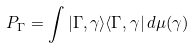Convert formula to latex. <formula><loc_0><loc_0><loc_500><loc_500>P _ { \Gamma } = \int | \Gamma , \gamma \rangle \langle \Gamma , \gamma | \, d \mu ( \gamma )</formula> 